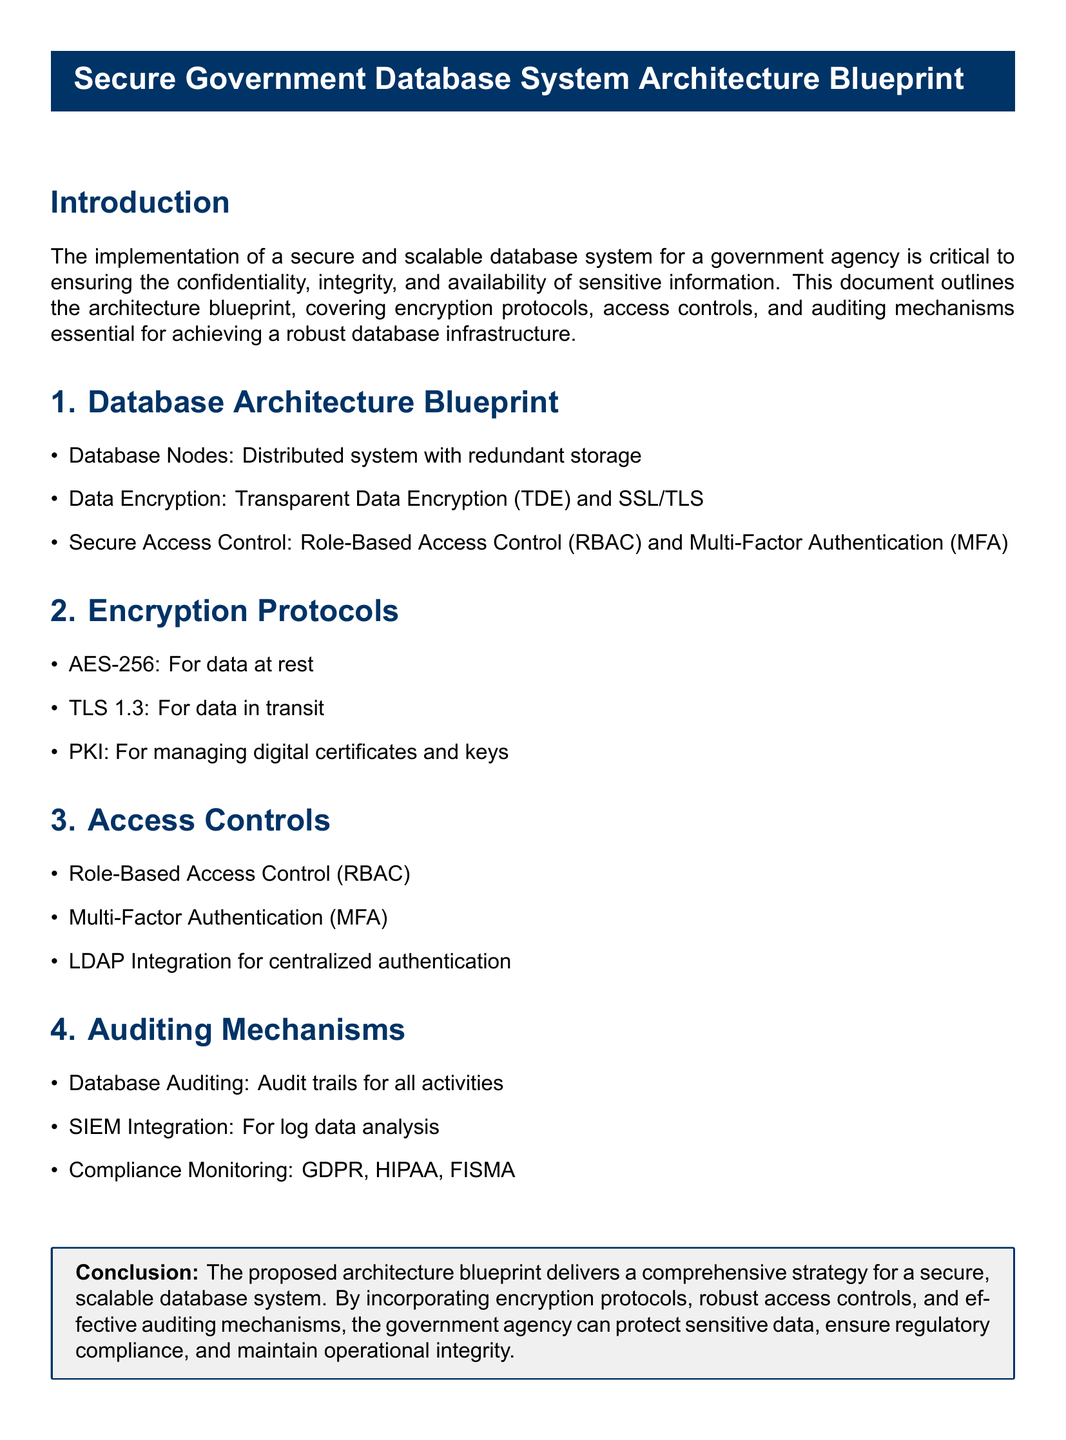What is the main purpose of the document? The document outlines the architecture blueprint for a secure and scalable database system for a government agency.
Answer: Secure and scalable database system What are the encryption protocols mentioned? The document lists specific encryption protocols included in the architecture blueprint.
Answer: AES-256, TLS 1.3, PKI What access control method is used? The document specifies a particular access control method within the architecture blueprint.
Answer: Role-Based Access Control (RBAC) Which compliance standards are monitored? The document mentions certain compliance standards that the auditing mechanisms address.
Answer: GDPR, HIPAA, FISMA What does TDE stand for? The document uses an abbreviation in the context of data encryption explanations.
Answer: Transparent Data Encryption What is the role of SIEM in the architecture? The document refers to a system used for a specific purpose within auditing mechanisms.
Answer: Log data analysis How is data at rest secured? The document indicates a specific method used to protect data stored within the system.
Answer: AES-256 What type of authentication is combined with access control? The document states an additional method used alongside the primary access control method.
Answer: Multi-Factor Authentication (MFA) What storage strategy is used for database nodes? The document outlines the method used to ensure data redundancy in database architecture.
Answer: Distributed system with redundant storage 